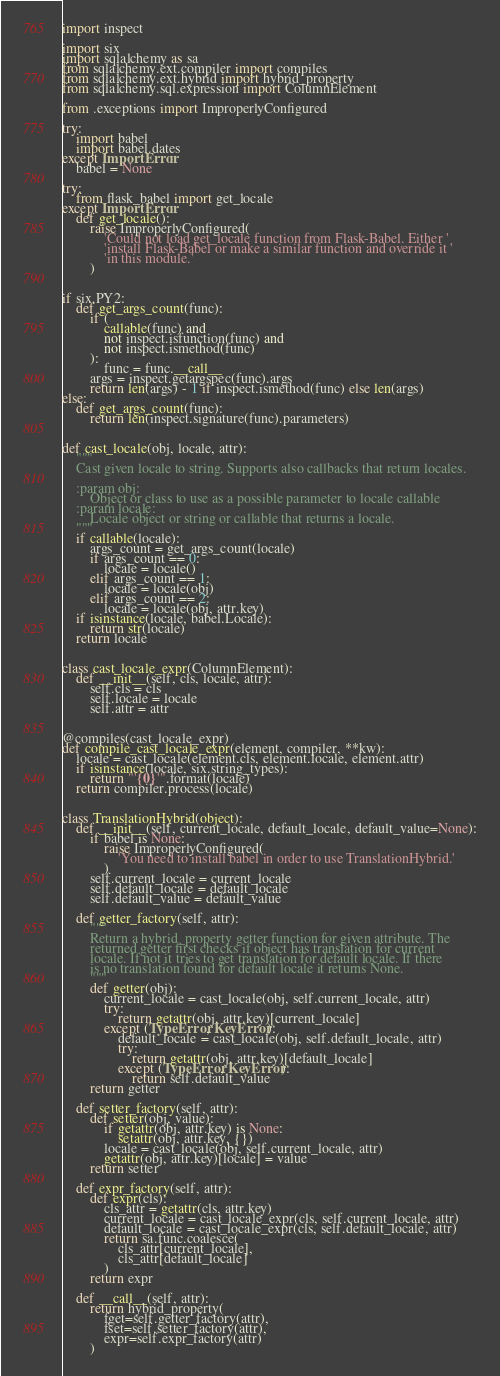<code> <loc_0><loc_0><loc_500><loc_500><_Python_>import inspect

import six
import sqlalchemy as sa
from sqlalchemy.ext.compiler import compiles
from sqlalchemy.ext.hybrid import hybrid_property
from sqlalchemy.sql.expression import ColumnElement

from .exceptions import ImproperlyConfigured

try:
    import babel
    import babel.dates
except ImportError:
    babel = None

try:
    from flask_babel import get_locale
except ImportError:
    def get_locale():
        raise ImproperlyConfigured(
            'Could not load get_locale function from Flask-Babel. Either '
            'install Flask-Babel or make a similar function and override it '
            'in this module.'
        )


if six.PY2:
    def get_args_count(func):
        if (
            callable(func) and
            not inspect.isfunction(func) and
            not inspect.ismethod(func)
        ):
            func = func.__call__
        args = inspect.getargspec(func).args
        return len(args) - 1 if inspect.ismethod(func) else len(args)
else:
    def get_args_count(func):
        return len(inspect.signature(func).parameters)


def cast_locale(obj, locale, attr):
    """
    Cast given locale to string. Supports also callbacks that return locales.

    :param obj:
        Object or class to use as a possible parameter to locale callable
    :param locale:
        Locale object or string or callable that returns a locale.
    """
    if callable(locale):
        args_count = get_args_count(locale)
        if args_count == 0:
            locale = locale()
        elif args_count == 1:
            locale = locale(obj)
        elif args_count == 2:
            locale = locale(obj, attr.key)
    if isinstance(locale, babel.Locale):
        return str(locale)
    return locale


class cast_locale_expr(ColumnElement):
    def __init__(self, cls, locale, attr):
        self.cls = cls
        self.locale = locale
        self.attr = attr


@compiles(cast_locale_expr)
def compile_cast_locale_expr(element, compiler, **kw):
    locale = cast_locale(element.cls, element.locale, element.attr)
    if isinstance(locale, six.string_types):
        return "'{0}'".format(locale)
    return compiler.process(locale)


class TranslationHybrid(object):
    def __init__(self, current_locale, default_locale, default_value=None):
        if babel is None:
            raise ImproperlyConfigured(
                'You need to install babel in order to use TranslationHybrid.'
            )
        self.current_locale = current_locale
        self.default_locale = default_locale
        self.default_value = default_value

    def getter_factory(self, attr):
        """
        Return a hybrid_property getter function for given attribute. The
        returned getter first checks if object has translation for current
        locale. If not it tries to get translation for default locale. If there
        is no translation found for default locale it returns None.
        """
        def getter(obj):
            current_locale = cast_locale(obj, self.current_locale, attr)
            try:
                return getattr(obj, attr.key)[current_locale]
            except (TypeError, KeyError):
                default_locale = cast_locale(obj, self.default_locale, attr)
                try:
                    return getattr(obj, attr.key)[default_locale]
                except (TypeError, KeyError):
                    return self.default_value
        return getter

    def setter_factory(self, attr):
        def setter(obj, value):
            if getattr(obj, attr.key) is None:
                setattr(obj, attr.key, {})
            locale = cast_locale(obj, self.current_locale, attr)
            getattr(obj, attr.key)[locale] = value
        return setter

    def expr_factory(self, attr):
        def expr(cls):
            cls_attr = getattr(cls, attr.key)
            current_locale = cast_locale_expr(cls, self.current_locale, attr)
            default_locale = cast_locale_expr(cls, self.default_locale, attr)
            return sa.func.coalesce(
                cls_attr[current_locale],
                cls_attr[default_locale]
            )
        return expr

    def __call__(self, attr):
        return hybrid_property(
            fget=self.getter_factory(attr),
            fset=self.setter_factory(attr),
            expr=self.expr_factory(attr)
        )
</code> 